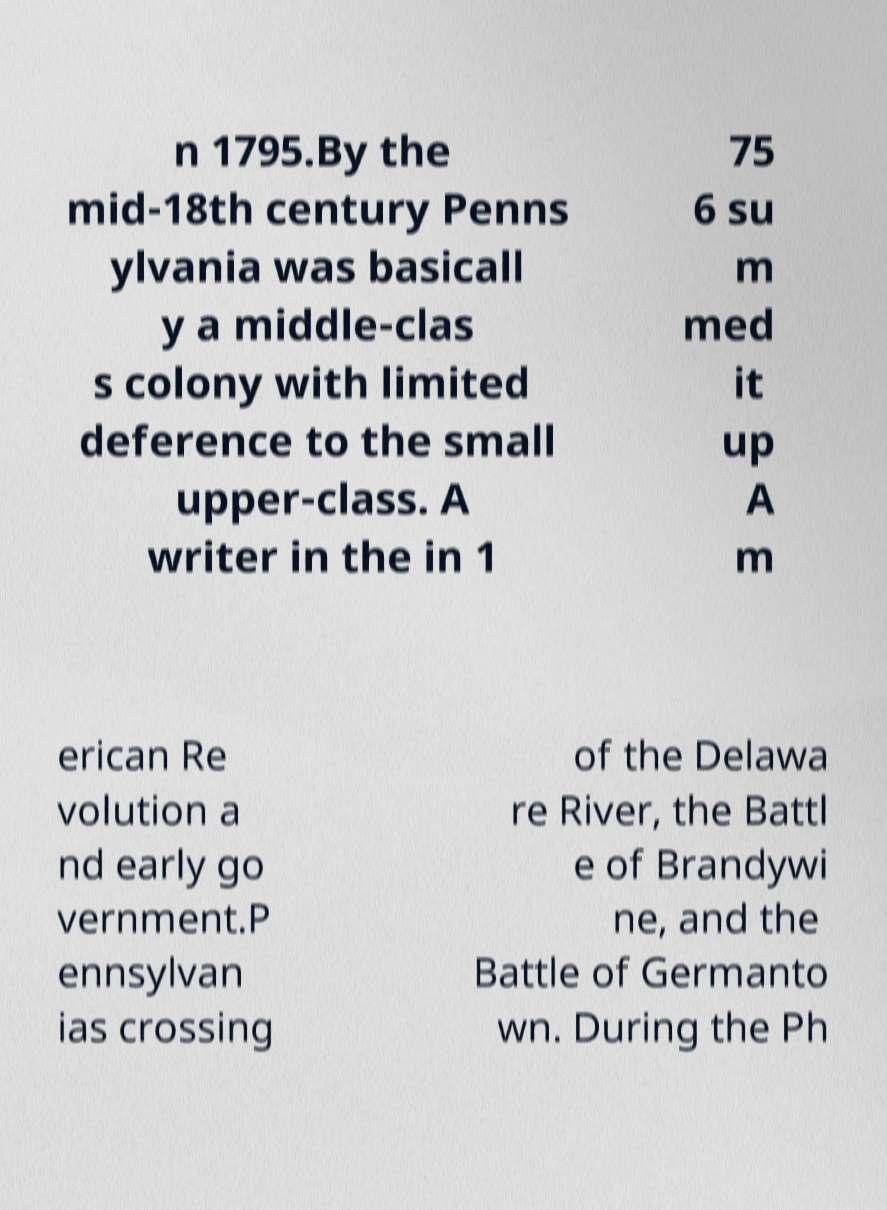For documentation purposes, I need the text within this image transcribed. Could you provide that? n 1795.By the mid-18th century Penns ylvania was basicall y a middle-clas s colony with limited deference to the small upper-class. A writer in the in 1 75 6 su m med it up A m erican Re volution a nd early go vernment.P ennsylvan ias crossing of the Delawa re River, the Battl e of Brandywi ne, and the Battle of Germanto wn. During the Ph 